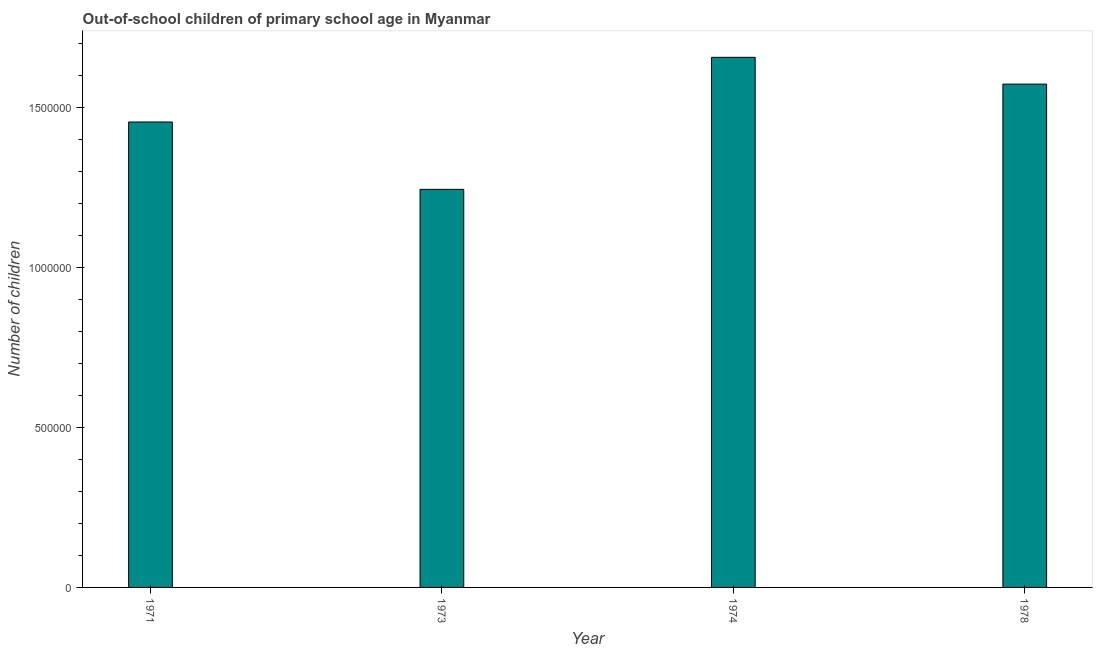What is the title of the graph?
Provide a succinct answer. Out-of-school children of primary school age in Myanmar. What is the label or title of the X-axis?
Your answer should be compact. Year. What is the label or title of the Y-axis?
Your answer should be very brief. Number of children. What is the number of out-of-school children in 1974?
Provide a succinct answer. 1.66e+06. Across all years, what is the maximum number of out-of-school children?
Your answer should be very brief. 1.66e+06. Across all years, what is the minimum number of out-of-school children?
Ensure brevity in your answer.  1.24e+06. In which year was the number of out-of-school children maximum?
Ensure brevity in your answer.  1974. What is the sum of the number of out-of-school children?
Give a very brief answer. 5.93e+06. What is the difference between the number of out-of-school children in 1974 and 1978?
Offer a terse response. 8.37e+04. What is the average number of out-of-school children per year?
Ensure brevity in your answer.  1.48e+06. What is the median number of out-of-school children?
Your answer should be compact. 1.51e+06. In how many years, is the number of out-of-school children greater than 1200000 ?
Ensure brevity in your answer.  4. Do a majority of the years between 1974 and 1971 (inclusive) have number of out-of-school children greater than 700000 ?
Provide a succinct answer. Yes. What is the ratio of the number of out-of-school children in 1971 to that in 1973?
Your answer should be very brief. 1.17. Is the number of out-of-school children in 1971 less than that in 1978?
Provide a short and direct response. Yes. What is the difference between the highest and the second highest number of out-of-school children?
Your answer should be very brief. 8.37e+04. What is the difference between the highest and the lowest number of out-of-school children?
Make the answer very short. 4.13e+05. In how many years, is the number of out-of-school children greater than the average number of out-of-school children taken over all years?
Your response must be concise. 2. Are all the bars in the graph horizontal?
Offer a very short reply. No. Are the values on the major ticks of Y-axis written in scientific E-notation?
Give a very brief answer. No. What is the Number of children in 1971?
Your answer should be compact. 1.45e+06. What is the Number of children in 1973?
Make the answer very short. 1.24e+06. What is the Number of children of 1974?
Your answer should be very brief. 1.66e+06. What is the Number of children in 1978?
Your answer should be compact. 1.57e+06. What is the difference between the Number of children in 1971 and 1973?
Make the answer very short. 2.10e+05. What is the difference between the Number of children in 1971 and 1974?
Provide a short and direct response. -2.02e+05. What is the difference between the Number of children in 1971 and 1978?
Offer a terse response. -1.18e+05. What is the difference between the Number of children in 1973 and 1974?
Your answer should be compact. -4.13e+05. What is the difference between the Number of children in 1973 and 1978?
Your answer should be very brief. -3.29e+05. What is the difference between the Number of children in 1974 and 1978?
Keep it short and to the point. 8.37e+04. What is the ratio of the Number of children in 1971 to that in 1973?
Ensure brevity in your answer.  1.17. What is the ratio of the Number of children in 1971 to that in 1974?
Offer a very short reply. 0.88. What is the ratio of the Number of children in 1971 to that in 1978?
Your answer should be very brief. 0.93. What is the ratio of the Number of children in 1973 to that in 1974?
Provide a succinct answer. 0.75. What is the ratio of the Number of children in 1973 to that in 1978?
Provide a succinct answer. 0.79. What is the ratio of the Number of children in 1974 to that in 1978?
Give a very brief answer. 1.05. 